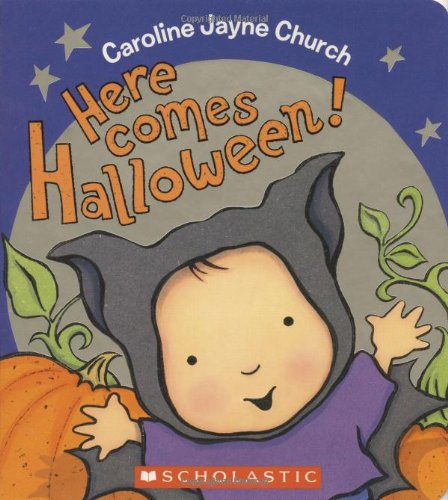What is the title of this book? The title of the book is 'Here Comes Halloween!', a festive children's story that explores the joys and excitement of Halloween through charming illustrations and narrative. 